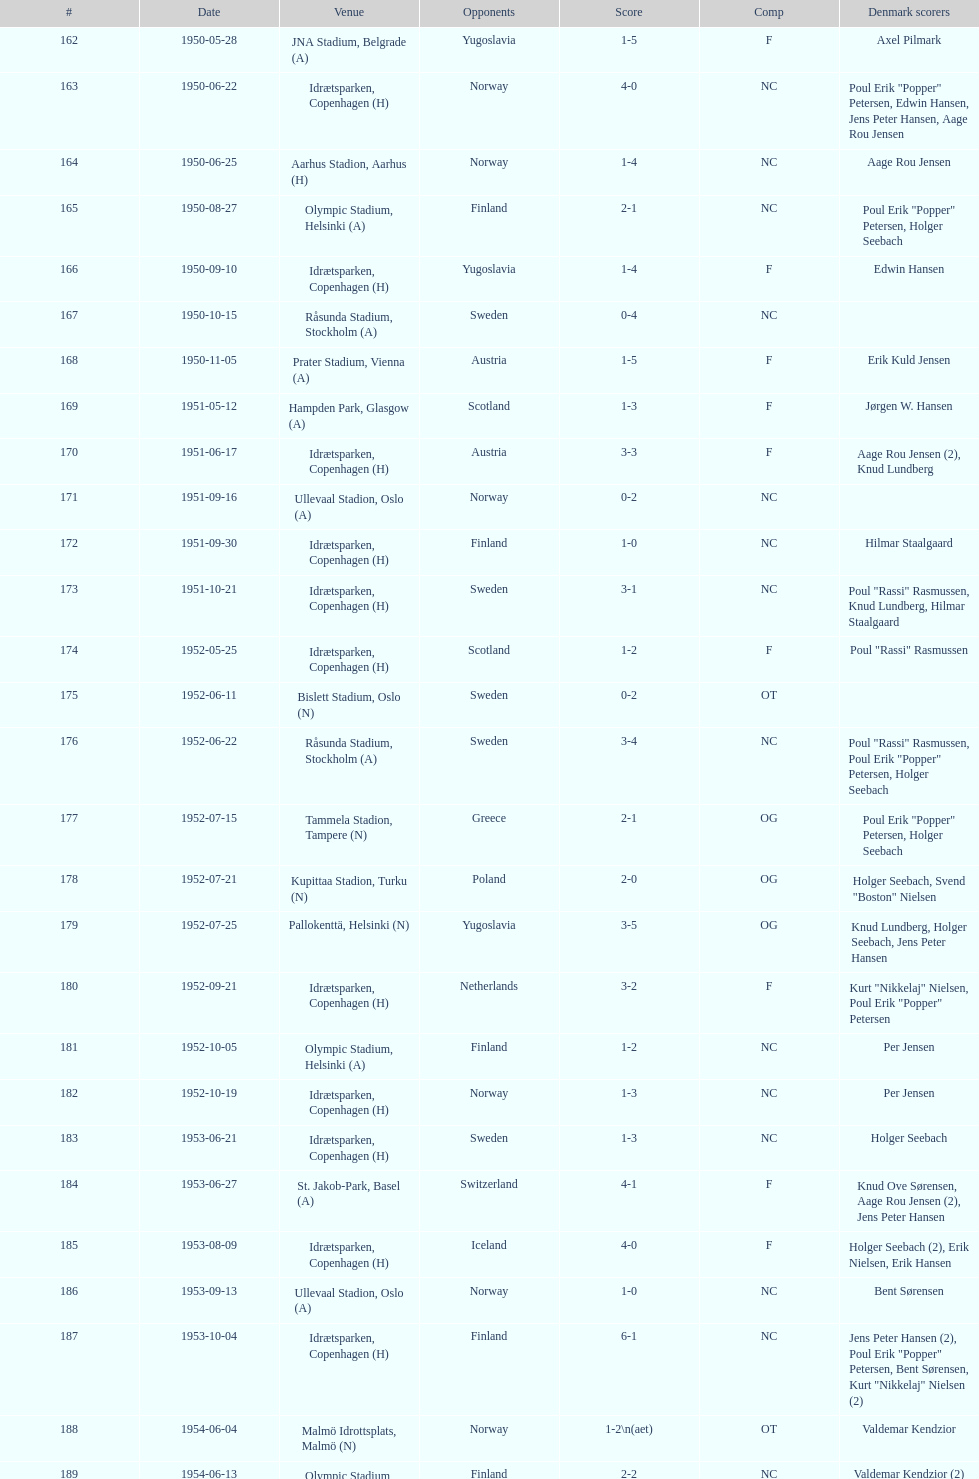How many instances were there when poland was the rival? 2. Would you mind parsing the complete table? {'header': ['#', 'Date', 'Venue', 'Opponents', 'Score', 'Comp', 'Denmark scorers'], 'rows': [['162', '1950-05-28', 'JNA Stadium, Belgrade (A)', 'Yugoslavia', '1-5', 'F', 'Axel Pilmark'], ['163', '1950-06-22', 'Idrætsparken, Copenhagen (H)', 'Norway', '4-0', 'NC', 'Poul Erik "Popper" Petersen, Edwin Hansen, Jens Peter Hansen, Aage Rou Jensen'], ['164', '1950-06-25', 'Aarhus Stadion, Aarhus (H)', 'Norway', '1-4', 'NC', 'Aage Rou Jensen'], ['165', '1950-08-27', 'Olympic Stadium, Helsinki (A)', 'Finland', '2-1', 'NC', 'Poul Erik "Popper" Petersen, Holger Seebach'], ['166', '1950-09-10', 'Idrætsparken, Copenhagen (H)', 'Yugoslavia', '1-4', 'F', 'Edwin Hansen'], ['167', '1950-10-15', 'Råsunda Stadium, Stockholm (A)', 'Sweden', '0-4', 'NC', ''], ['168', '1950-11-05', 'Prater Stadium, Vienna (A)', 'Austria', '1-5', 'F', 'Erik Kuld Jensen'], ['169', '1951-05-12', 'Hampden Park, Glasgow (A)', 'Scotland', '1-3', 'F', 'Jørgen W. Hansen'], ['170', '1951-06-17', 'Idrætsparken, Copenhagen (H)', 'Austria', '3-3', 'F', 'Aage Rou Jensen (2), Knud Lundberg'], ['171', '1951-09-16', 'Ullevaal Stadion, Oslo (A)', 'Norway', '0-2', 'NC', ''], ['172', '1951-09-30', 'Idrætsparken, Copenhagen (H)', 'Finland', '1-0', 'NC', 'Hilmar Staalgaard'], ['173', '1951-10-21', 'Idrætsparken, Copenhagen (H)', 'Sweden', '3-1', 'NC', 'Poul "Rassi" Rasmussen, Knud Lundberg, Hilmar Staalgaard'], ['174', '1952-05-25', 'Idrætsparken, Copenhagen (H)', 'Scotland', '1-2', 'F', 'Poul "Rassi" Rasmussen'], ['175', '1952-06-11', 'Bislett Stadium, Oslo (N)', 'Sweden', '0-2', 'OT', ''], ['176', '1952-06-22', 'Råsunda Stadium, Stockholm (A)', 'Sweden', '3-4', 'NC', 'Poul "Rassi" Rasmussen, Poul Erik "Popper" Petersen, Holger Seebach'], ['177', '1952-07-15', 'Tammela Stadion, Tampere (N)', 'Greece', '2-1', 'OG', 'Poul Erik "Popper" Petersen, Holger Seebach'], ['178', '1952-07-21', 'Kupittaa Stadion, Turku (N)', 'Poland', '2-0', 'OG', 'Holger Seebach, Svend "Boston" Nielsen'], ['179', '1952-07-25', 'Pallokenttä, Helsinki (N)', 'Yugoslavia', '3-5', 'OG', 'Knud Lundberg, Holger Seebach, Jens Peter Hansen'], ['180', '1952-09-21', 'Idrætsparken, Copenhagen (H)', 'Netherlands', '3-2', 'F', 'Kurt "Nikkelaj" Nielsen, Poul Erik "Popper" Petersen'], ['181', '1952-10-05', 'Olympic Stadium, Helsinki (A)', 'Finland', '1-2', 'NC', 'Per Jensen'], ['182', '1952-10-19', 'Idrætsparken, Copenhagen (H)', 'Norway', '1-3', 'NC', 'Per Jensen'], ['183', '1953-06-21', 'Idrætsparken, Copenhagen (H)', 'Sweden', '1-3', 'NC', 'Holger Seebach'], ['184', '1953-06-27', 'St. Jakob-Park, Basel (A)', 'Switzerland', '4-1', 'F', 'Knud Ove Sørensen, Aage Rou Jensen (2), Jens Peter Hansen'], ['185', '1953-08-09', 'Idrætsparken, Copenhagen (H)', 'Iceland', '4-0', 'F', 'Holger Seebach (2), Erik Nielsen, Erik Hansen'], ['186', '1953-09-13', 'Ullevaal Stadion, Oslo (A)', 'Norway', '1-0', 'NC', 'Bent Sørensen'], ['187', '1953-10-04', 'Idrætsparken, Copenhagen (H)', 'Finland', '6-1', 'NC', 'Jens Peter Hansen (2), Poul Erik "Popper" Petersen, Bent Sørensen, Kurt "Nikkelaj" Nielsen (2)'], ['188', '1954-06-04', 'Malmö Idrottsplats, Malmö (N)', 'Norway', '1-2\\n(aet)', 'OT', 'Valdemar Kendzior'], ['189', '1954-06-13', 'Olympic Stadium, Helsinki (A)', 'Finland', '2-2', 'NC', 'Valdemar Kendzior (2)'], ['190', '1954-09-19', 'Idrætsparken, Copenhagen (H)', 'Switzerland', '1-1', 'F', 'Jørgen Olesen'], ['191', '1954-10-10', 'Råsunda Stadium, Stockholm (A)', 'Sweden', '2-5', 'NC', 'Jens Peter Hansen, Bent Sørensen'], ['192', '1954-10-31', 'Idrætsparken, Copenhagen (H)', 'Norway', '0-1', 'NC', ''], ['193', '1955-03-13', 'Olympic Stadium, Amsterdam (A)', 'Netherlands', '1-1', 'F', 'Vagn Birkeland'], ['194', '1955-05-15', 'Idrætsparken, Copenhagen (H)', 'Hungary', '0-6', 'F', ''], ['195', '1955-06-19', 'Idrætsparken, Copenhagen (H)', 'Finland', '2-1', 'NC', 'Jens Peter Hansen (2)'], ['196', '1955-06-03', 'Melavollur, Reykjavík (A)', 'Iceland', '4-0', 'F', 'Aage Rou Jensen, Jens Peter Hansen, Poul Pedersen (2)'], ['197', '1955-09-11', 'Ullevaal Stadion, Oslo (A)', 'Norway', '1-1', 'NC', 'Jørgen Jacobsen'], ['198', '1955-10-02', 'Idrætsparken, Copenhagen (H)', 'England', '1-5', 'NC', 'Knud Lundberg'], ['199', '1955-10-16', 'Idrætsparken, Copenhagen (H)', 'Sweden', '3-3', 'NC', 'Ove Andersen (2), Knud Lundberg'], ['200', '1956-05-23', 'Dynamo Stadium, Moscow (A)', 'USSR', '1-5', 'F', 'Knud Lundberg'], ['201', '1956-06-24', 'Idrætsparken, Copenhagen (H)', 'Norway', '2-3', 'NC', 'Knud Lundberg, Poul Pedersen'], ['202', '1956-07-01', 'Idrætsparken, Copenhagen (H)', 'USSR', '2-5', 'F', 'Ove Andersen, Aage Rou Jensen'], ['203', '1956-09-16', 'Olympic Stadium, Helsinki (A)', 'Finland', '4-0', 'NC', 'Poul Pedersen, Jørgen Hansen, Ove Andersen (2)'], ['204', '1956-10-03', 'Dalymount Park, Dublin (A)', 'Republic of Ireland', '1-2', 'WCQ', 'Aage Rou Jensen'], ['205', '1956-10-21', 'Råsunda Stadium, Stockholm (A)', 'Sweden', '1-1', 'NC', 'Jens Peter Hansen'], ['206', '1956-11-04', 'Idrætsparken, Copenhagen (H)', 'Netherlands', '2-2', 'F', 'Jørgen Olesen, Knud Lundberg'], ['207', '1956-12-05', 'Molineux, Wolverhampton (A)', 'England', '2-5', 'WCQ', 'Ove Bech Nielsen (2)'], ['208', '1957-05-15', 'Idrætsparken, Copenhagen (H)', 'England', '1-4', 'WCQ', 'John Jensen'], ['209', '1957-05-26', 'Idrætsparken, Copenhagen (H)', 'Bulgaria', '1-1', 'F', 'Aage Rou Jensen'], ['210', '1957-06-18', 'Olympic Stadium, Helsinki (A)', 'Finland', '0-2', 'OT', ''], ['211', '1957-06-19', 'Tammela Stadion, Tampere (N)', 'Norway', '2-0', 'OT', 'Egon Jensen, Jørgen Hansen'], ['212', '1957-06-30', 'Idrætsparken, Copenhagen (H)', 'Sweden', '1-2', 'NC', 'Jens Peter Hansen'], ['213', '1957-07-10', 'Laugardalsvöllur, Reykjavík (A)', 'Iceland', '6-2', 'OT', 'Egon Jensen (3), Poul Pedersen, Jens Peter Hansen (2)'], ['214', '1957-09-22', 'Ullevaal Stadion, Oslo (A)', 'Norway', '2-2', 'NC', 'Poul Pedersen, Peder Kjær'], ['215', '1957-10-02', 'Idrætsparken, Copenhagen (H)', 'Republic of Ireland', '0-2', 'WCQ', ''], ['216', '1957-10-13', 'Idrætsparken, Copenhagen (H)', 'Finland', '3-0', 'NC', 'Finn Alfred Hansen, Ove Bech Nielsen, Mogens Machon'], ['217', '1958-05-15', 'Aarhus Stadion, Aarhus (H)', 'Curaçao', '3-2', 'F', 'Poul Pedersen, Henning Enoksen (2)'], ['218', '1958-05-25', 'Idrætsparken, Copenhagen (H)', 'Poland', '3-2', 'F', 'Jørn Sørensen, Poul Pedersen (2)'], ['219', '1958-06-29', 'Idrætsparken, Copenhagen (H)', 'Norway', '1-2', 'NC', 'Poul Pedersen'], ['220', '1958-09-14', 'Olympic Stadium, Helsinki (A)', 'Finland', '4-1', 'NC', 'Poul Pedersen, Mogens Machon, John Danielsen (2)'], ['221', '1958-09-24', 'Idrætsparken, Copenhagen (H)', 'West Germany', '1-1', 'F', 'Henning Enoksen'], ['222', '1958-10-15', 'Idrætsparken, Copenhagen (H)', 'Netherlands', '1-5', 'F', 'Henning Enoksen'], ['223', '1958-10-26', 'Råsunda Stadium, Stockholm (A)', 'Sweden', '4-4', 'NC', 'Ole Madsen (2), Henning Enoksen, Jørn Sørensen'], ['224', '1959-06-21', 'Idrætsparken, Copenhagen (H)', 'Sweden', '0-6', 'NC', ''], ['225', '1959-06-26', 'Laugardalsvöllur, Reykjavík (A)', 'Iceland', '4-2', 'OGQ', 'Jens Peter Hansen (2), Ole Madsen (2)'], ['226', '1959-07-02', 'Idrætsparken, Copenhagen (H)', 'Norway', '2-1', 'OGQ', 'Henning Enoksen, Ole Madsen'], ['227', '1959-08-18', 'Idrætsparken, Copenhagen (H)', 'Iceland', '1-1', 'OGQ', 'Henning Enoksen'], ['228', '1959-09-13', 'Ullevaal Stadion, Oslo (A)', 'Norway', '4-2', 'OGQ\\nNC', 'Harald Nielsen, Henning Enoksen (2), Poul Pedersen'], ['229', '1959-09-23', 'Idrætsparken, Copenhagen (H)', 'Czechoslovakia', '2-2', 'ENQ', 'Poul Pedersen, Bent Hansen'], ['230', '1959-10-04', 'Idrætsparken, Copenhagen (H)', 'Finland', '4-0', 'NC', 'Harald Nielsen (3), John Kramer'], ['231', '1959-10-18', 'Stadion Za Lužánkami, Brno (A)', 'Czechoslovakia', '1-5', 'ENQ', 'John Kramer'], ['232', '1959-12-02', 'Olympic Stadium, Athens (A)', 'Greece', '3-1', 'F', 'Henning Enoksen (2), Poul Pedersen'], ['233', '1959-12-06', 'Vasil Levski National Stadium, Sofia (A)', 'Bulgaria', '1-2', 'F', 'Henning Enoksen']]} 